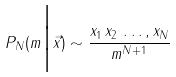Convert formula to latex. <formula><loc_0><loc_0><loc_500><loc_500>P _ { N } ( m \Big | \vec { x } ) \sim \frac { x _ { 1 } \, x _ { 2 } \, \dots , x _ { N } } { m ^ { N + 1 } }</formula> 